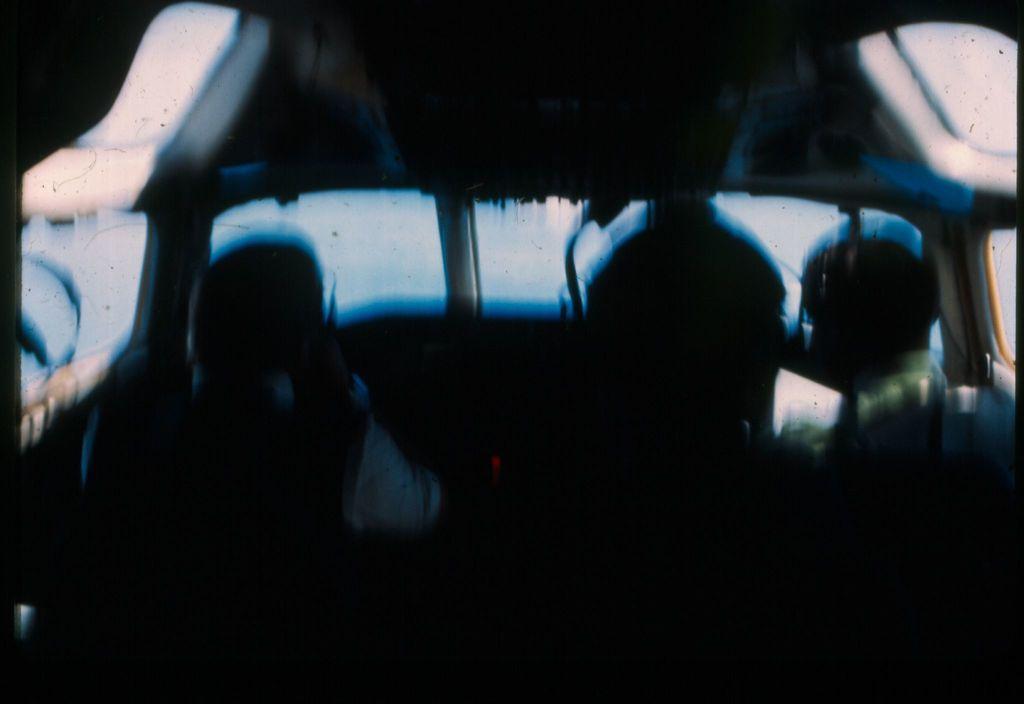In one or two sentences, can you explain what this image depicts? This is an edited image and a inside view of the vehicle , where there are people. 